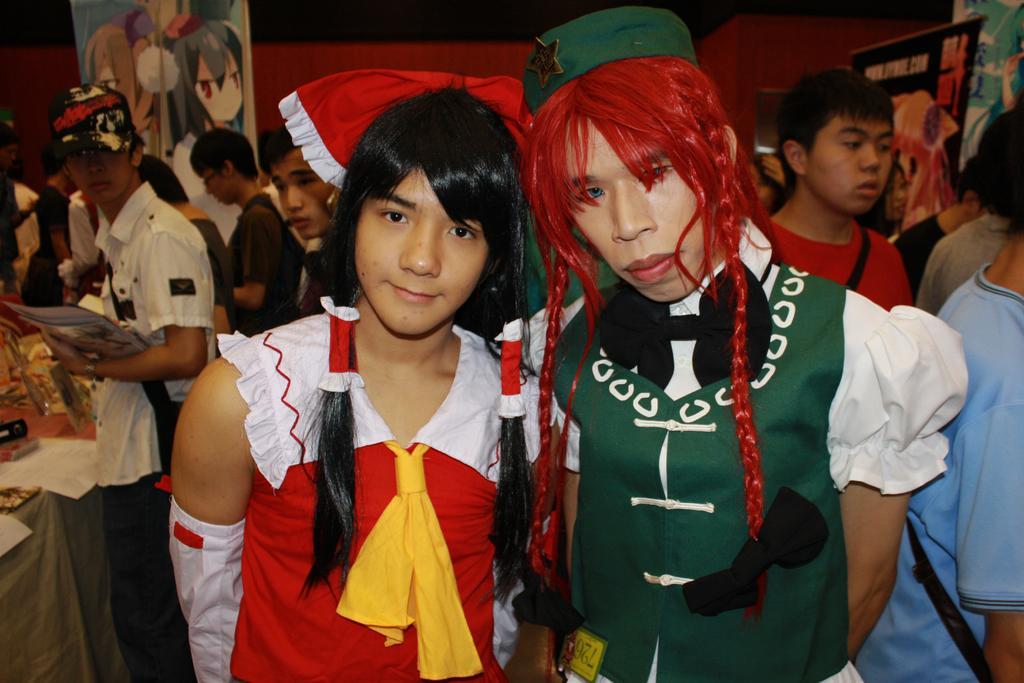Describe this image in one or two sentences. In front of the picture, we see two men wearing the costumes are standing. They are posing for the photo. Behind them, we see many people are standing. The man on the left side who is wearing the white shirt is holding a book or a file. In front of him, we see a table on which papers, glasses and some other things are placed. In the background, we see a brown wall and boards in different colors. 